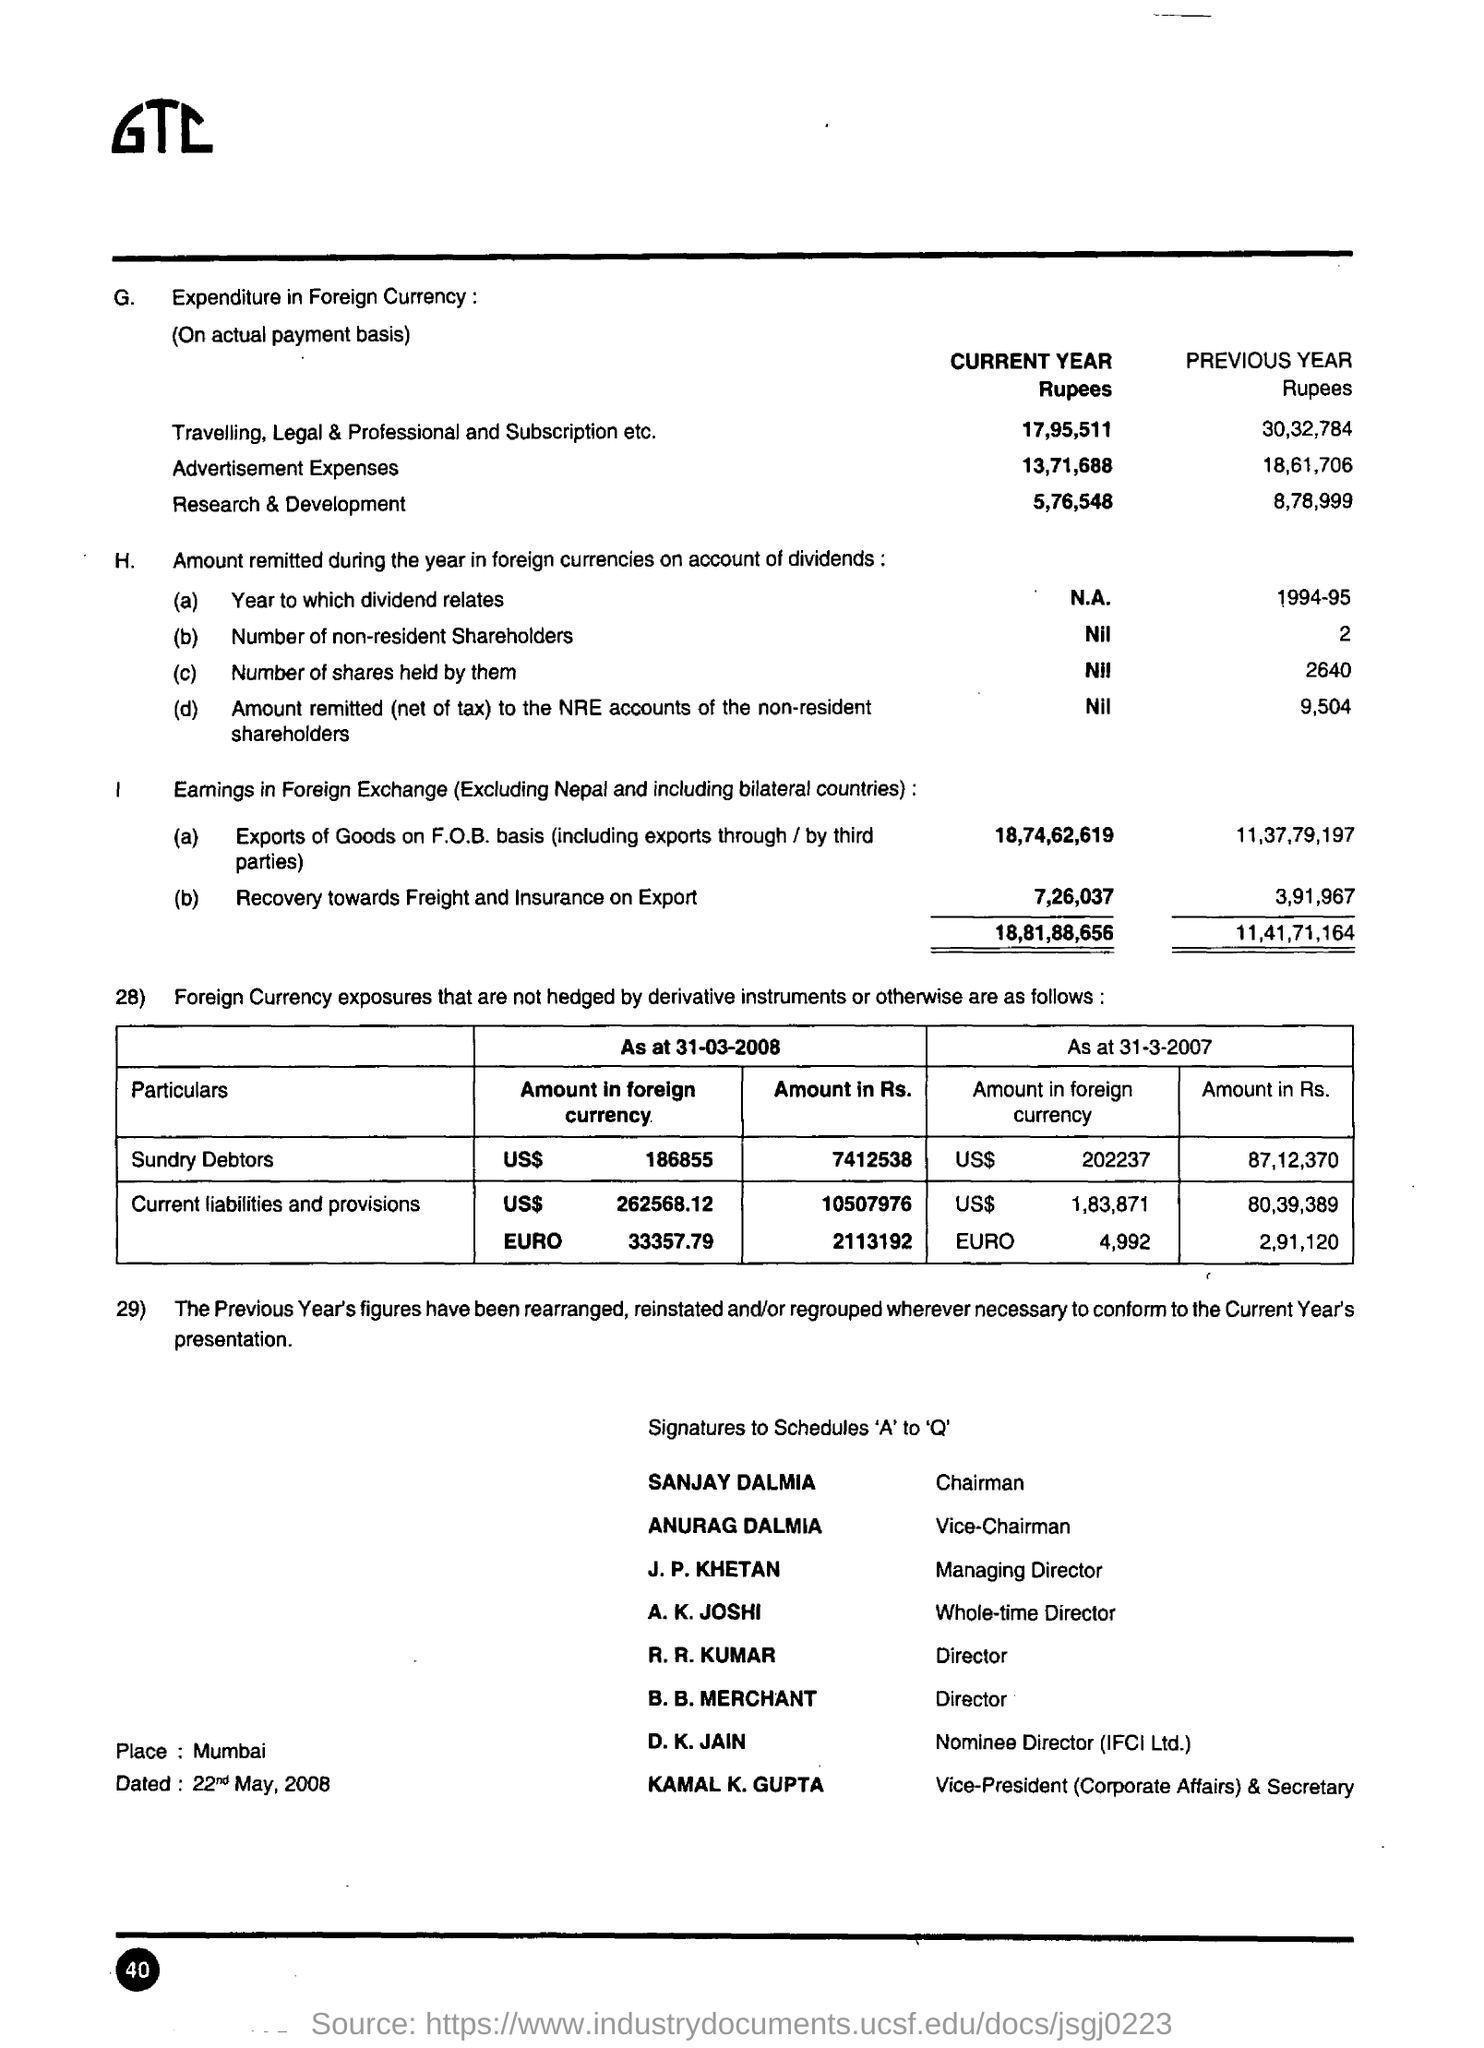Who is the chairman ?
Offer a very short reply. Sanjay Dalmia. Who is the vice chairman ?
Your answer should be very brief. Anurag Dalmia. What is the place mentioned?
Keep it short and to the point. Mumbai. What is the designation of j.p khetan
Your response must be concise. Managing director. What is the recovery towards freight and insurance on export for current year in rupees ?
Provide a succinct answer. 7,26,037. What is the recovery towards freight and insurance on export for previous year in rupees
Ensure brevity in your answer.  3,91,967. 